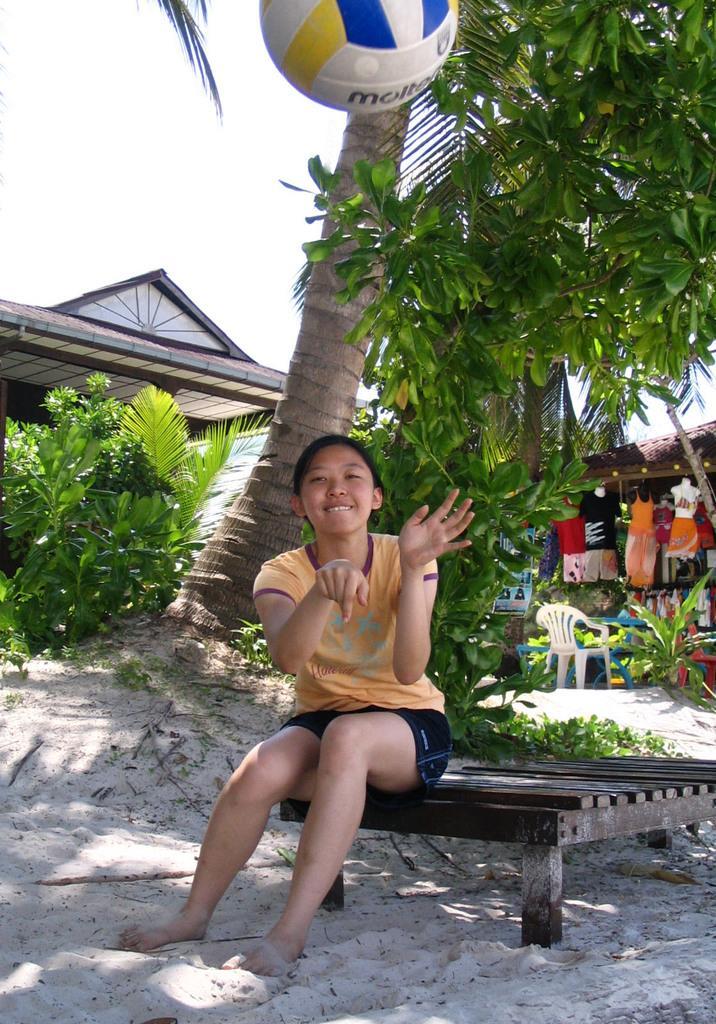How would you summarize this image in a sentence or two? a person is sitting on a wooden bench is throwing a ball. behind her there are trees and a building. at the left corner there are clothes hanging and a white chair present. 